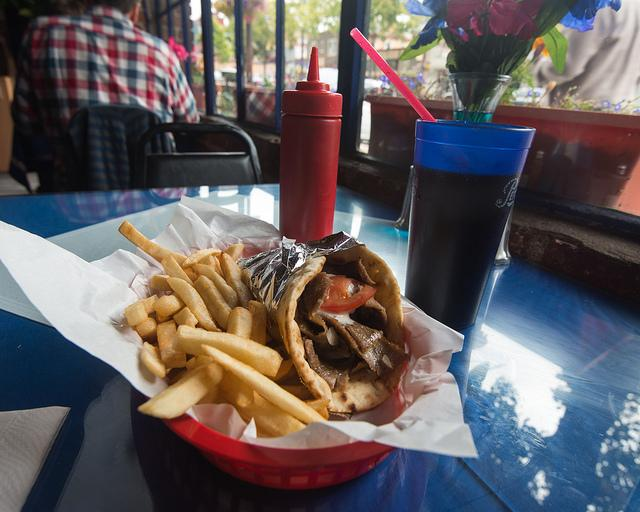What type of food is in the tinfoil? Please explain your reasoning. laffa. The pita like bread with meat inside  is common with this iraqi cuisine. 